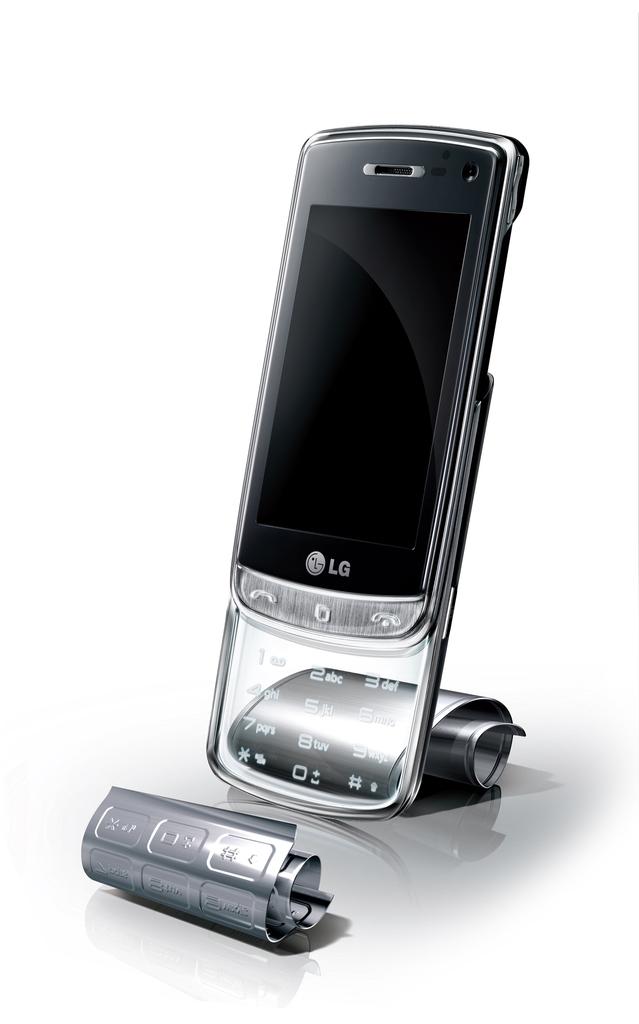Is this an lg phone?
Your response must be concise. Yes. What is the brand of this phone?
Ensure brevity in your answer.  Lg. 